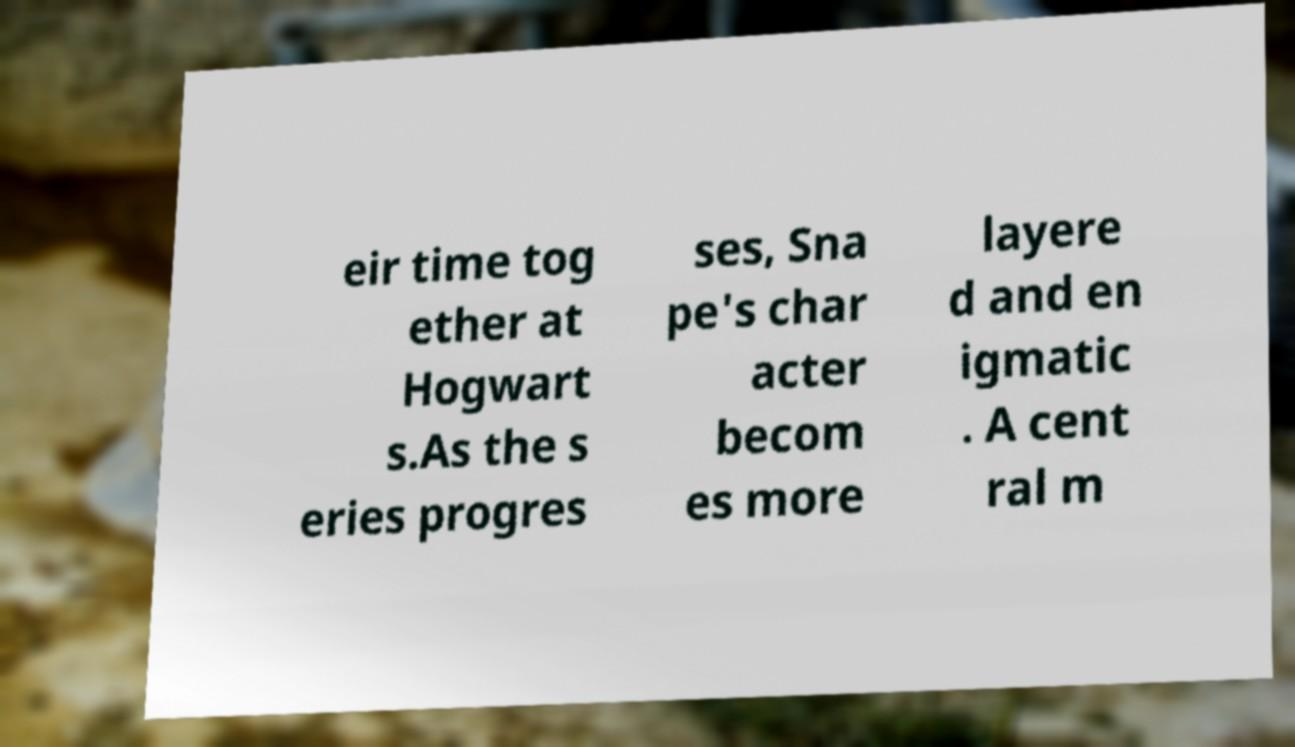For documentation purposes, I need the text within this image transcribed. Could you provide that? eir time tog ether at Hogwart s.As the s eries progres ses, Sna pe's char acter becom es more layere d and en igmatic . A cent ral m 